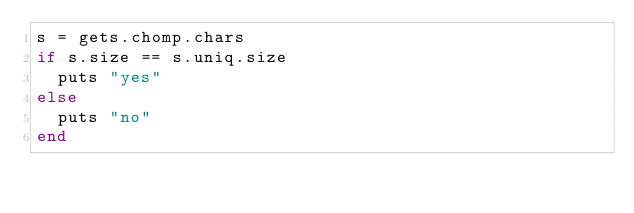Convert code to text. <code><loc_0><loc_0><loc_500><loc_500><_Ruby_>s = gets.chomp.chars
if s.size == s.uniq.size
  puts "yes"
else
  puts "no"
end</code> 